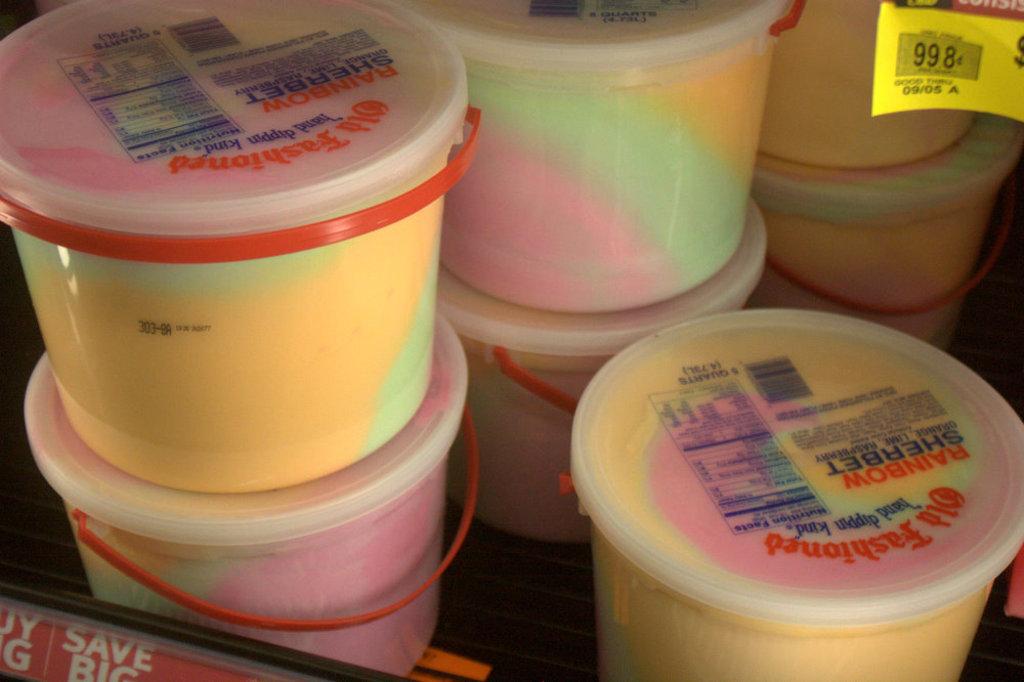What is the brand of sherbet?
Make the answer very short. Old fashioned. 